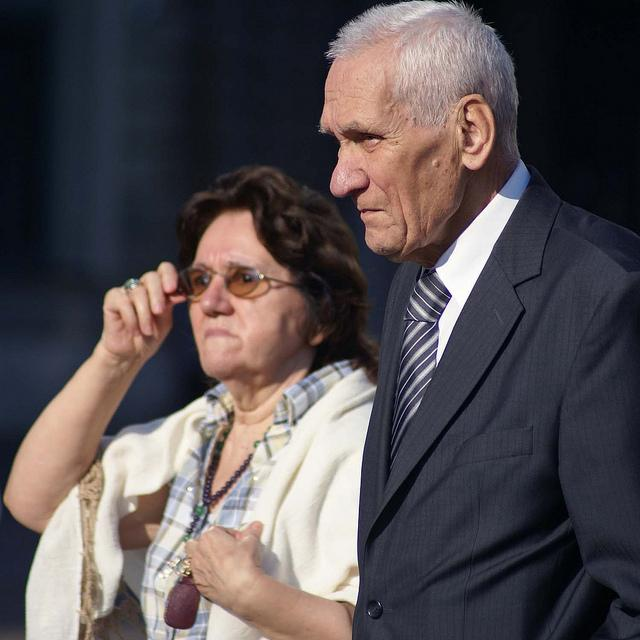Why are her glasses that color? Please explain your reasoning. sunlight. They are used to protect the eyes from the sun and the shade of them help prevent all the sunlight from reaching the eyes. 